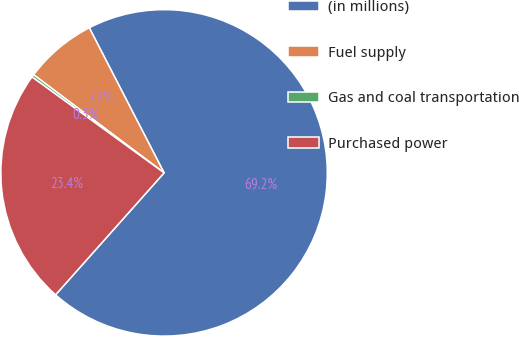Convert chart to OTSL. <chart><loc_0><loc_0><loc_500><loc_500><pie_chart><fcel>(in millions)<fcel>Fuel supply<fcel>Gas and coal transportation<fcel>Purchased power<nl><fcel>69.15%<fcel>7.16%<fcel>0.27%<fcel>23.42%<nl></chart> 